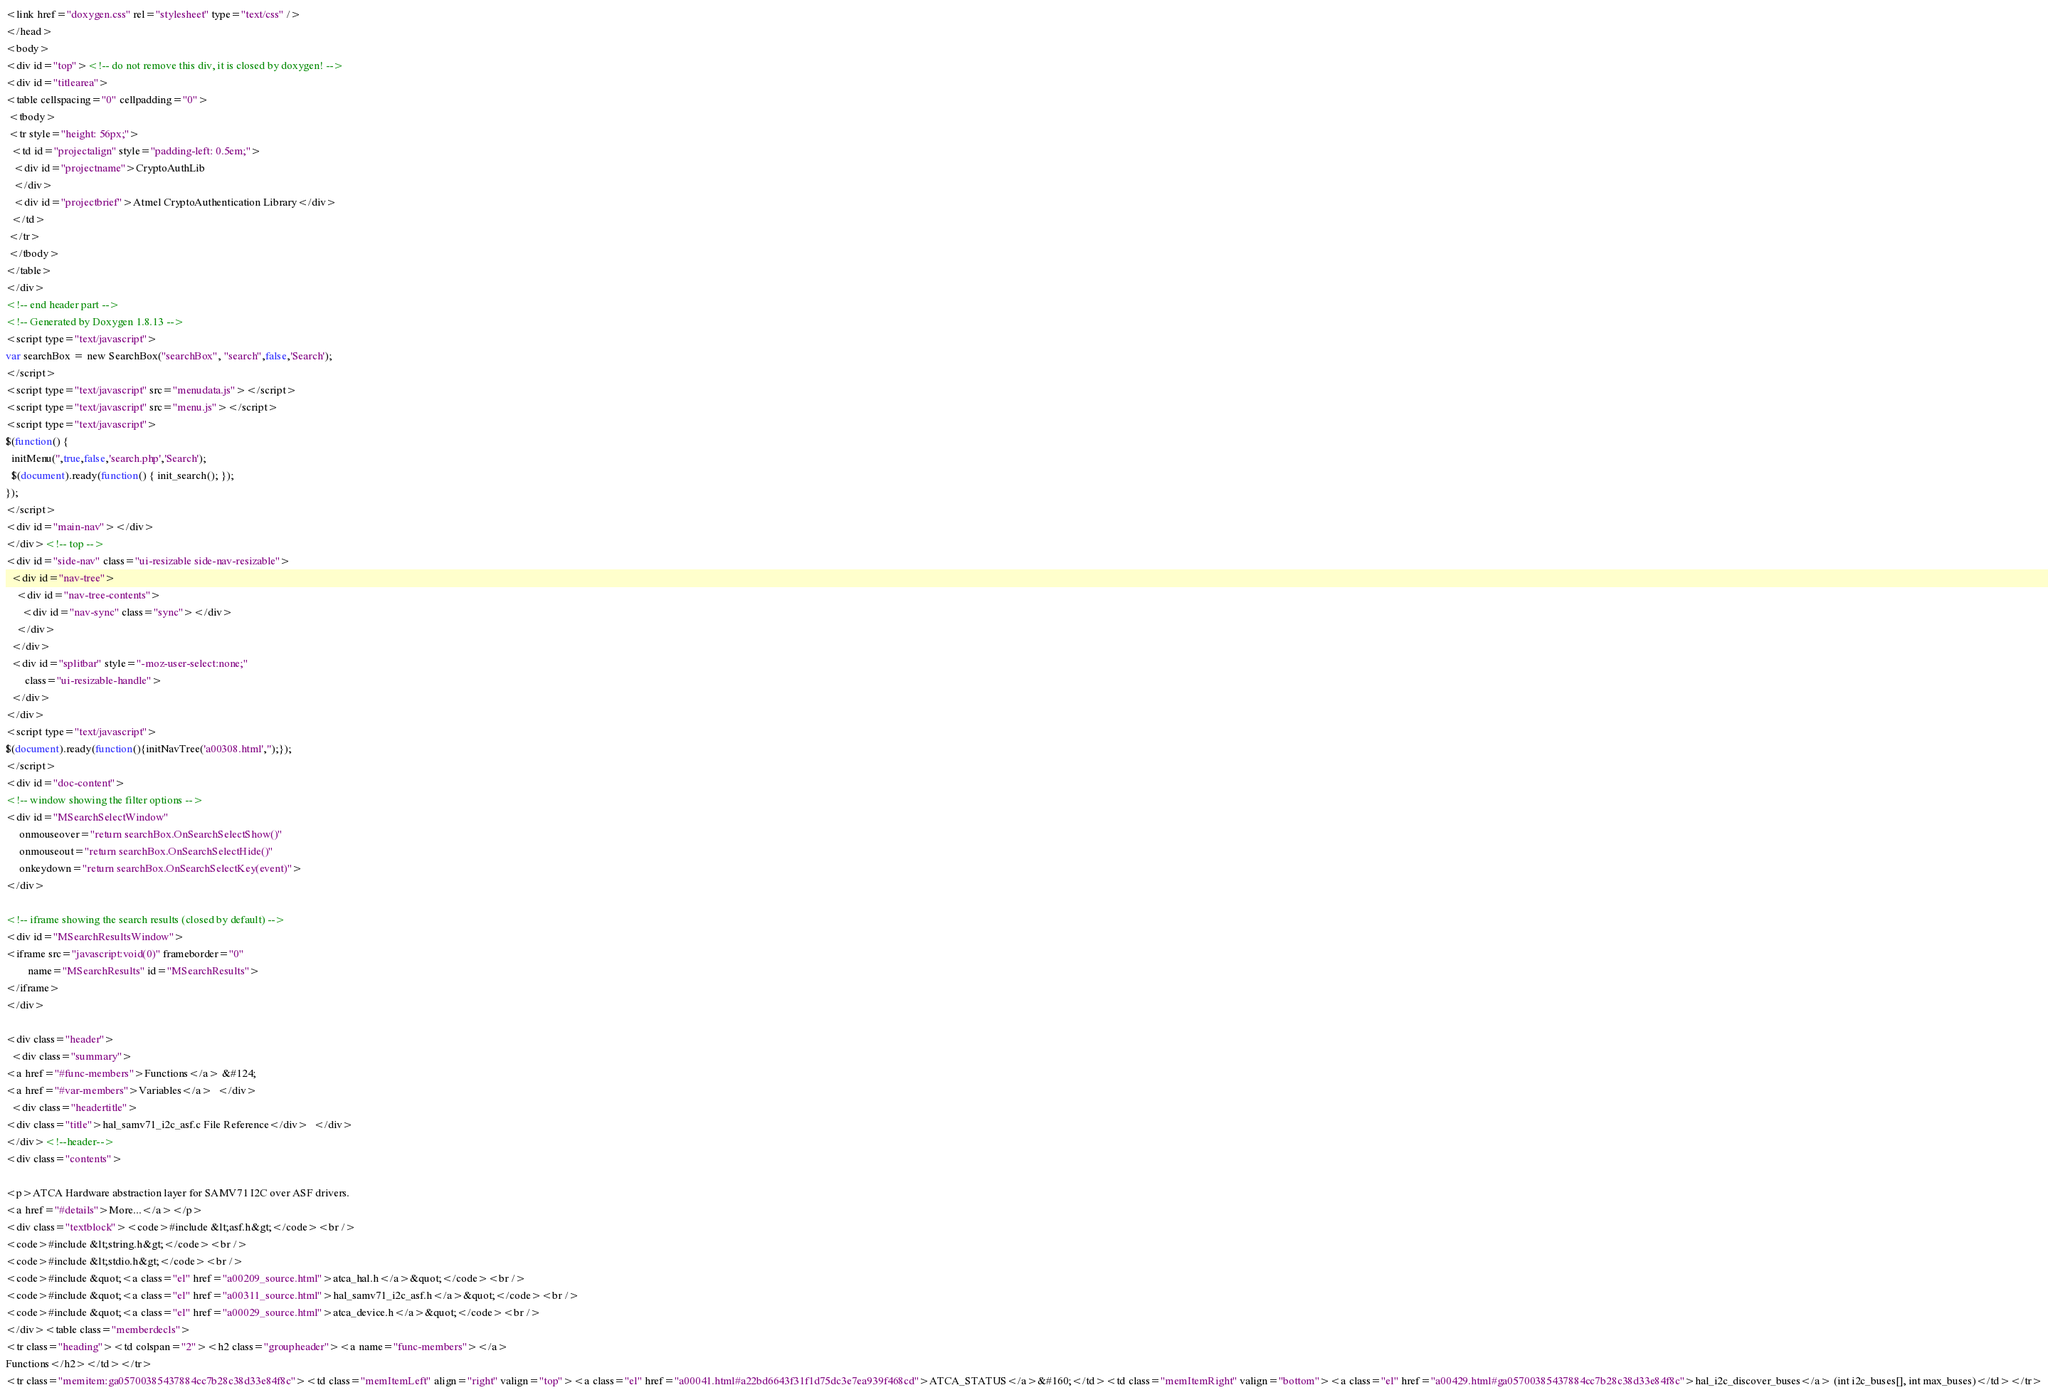<code> <loc_0><loc_0><loc_500><loc_500><_HTML_><link href="doxygen.css" rel="stylesheet" type="text/css" />
</head>
<body>
<div id="top"><!-- do not remove this div, it is closed by doxygen! -->
<div id="titlearea">
<table cellspacing="0" cellpadding="0">
 <tbody>
 <tr style="height: 56px;">
  <td id="projectalign" style="padding-left: 0.5em;">
   <div id="projectname">CryptoAuthLib
   </div>
   <div id="projectbrief">Atmel CryptoAuthentication Library</div>
  </td>
 </tr>
 </tbody>
</table>
</div>
<!-- end header part -->
<!-- Generated by Doxygen 1.8.13 -->
<script type="text/javascript">
var searchBox = new SearchBox("searchBox", "search",false,'Search');
</script>
<script type="text/javascript" src="menudata.js"></script>
<script type="text/javascript" src="menu.js"></script>
<script type="text/javascript">
$(function() {
  initMenu('',true,false,'search.php','Search');
  $(document).ready(function() { init_search(); });
});
</script>
<div id="main-nav"></div>
</div><!-- top -->
<div id="side-nav" class="ui-resizable side-nav-resizable">
  <div id="nav-tree">
    <div id="nav-tree-contents">
      <div id="nav-sync" class="sync"></div>
    </div>
  </div>
  <div id="splitbar" style="-moz-user-select:none;" 
       class="ui-resizable-handle">
  </div>
</div>
<script type="text/javascript">
$(document).ready(function(){initNavTree('a00308.html','');});
</script>
<div id="doc-content">
<!-- window showing the filter options -->
<div id="MSearchSelectWindow"
     onmouseover="return searchBox.OnSearchSelectShow()"
     onmouseout="return searchBox.OnSearchSelectHide()"
     onkeydown="return searchBox.OnSearchSelectKey(event)">
</div>

<!-- iframe showing the search results (closed by default) -->
<div id="MSearchResultsWindow">
<iframe src="javascript:void(0)" frameborder="0" 
        name="MSearchResults" id="MSearchResults">
</iframe>
</div>

<div class="header">
  <div class="summary">
<a href="#func-members">Functions</a> &#124;
<a href="#var-members">Variables</a>  </div>
  <div class="headertitle">
<div class="title">hal_samv71_i2c_asf.c File Reference</div>  </div>
</div><!--header-->
<div class="contents">

<p>ATCA Hardware abstraction layer for SAMV71 I2C over ASF drivers.  
<a href="#details">More...</a></p>
<div class="textblock"><code>#include &lt;asf.h&gt;</code><br />
<code>#include &lt;string.h&gt;</code><br />
<code>#include &lt;stdio.h&gt;</code><br />
<code>#include &quot;<a class="el" href="a00209_source.html">atca_hal.h</a>&quot;</code><br />
<code>#include &quot;<a class="el" href="a00311_source.html">hal_samv71_i2c_asf.h</a>&quot;</code><br />
<code>#include &quot;<a class="el" href="a00029_source.html">atca_device.h</a>&quot;</code><br />
</div><table class="memberdecls">
<tr class="heading"><td colspan="2"><h2 class="groupheader"><a name="func-members"></a>
Functions</h2></td></tr>
<tr class="memitem:ga05700385437884cc7b28c38d33e84f8c"><td class="memItemLeft" align="right" valign="top"><a class="el" href="a00041.html#a22bd6643f31f1d75dc3e7ea939f468cd">ATCA_STATUS</a>&#160;</td><td class="memItemRight" valign="bottom"><a class="el" href="a00429.html#ga05700385437884cc7b28c38d33e84f8c">hal_i2c_discover_buses</a> (int i2c_buses[], int max_buses)</td></tr></code> 